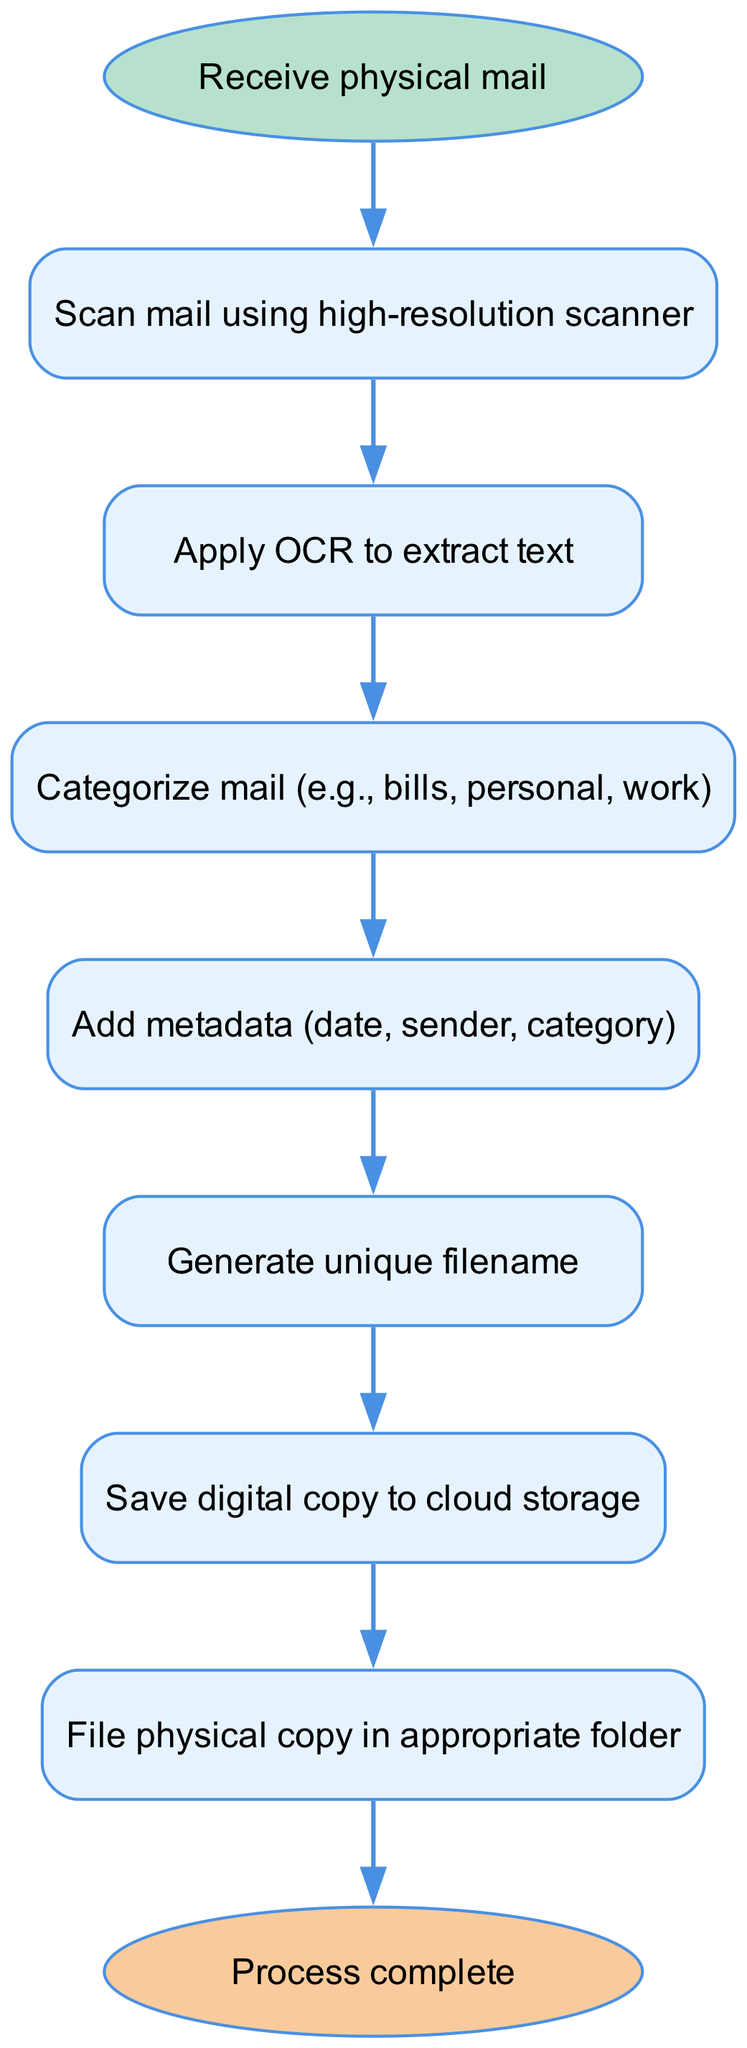What is the first step in the flowchart? The first node in the diagram is labeled "Receive physical mail," which represents the initial action taken in the digitization process.
Answer: Receive physical mail How many nodes are present in the diagram? By counting, there are a total of nine nodes listed in the data provided, including both the start and end nodes.
Answer: Nine What step comes after "Apply OCR to extract text"? The edge leading from "Apply OCR to extract text" points to the next node, which is "Categorize mail (e.g., bills, personal, work)," indicating the subsequent action after applying OCR.
Answer: Categorize mail (e.g., bills, personal, work) What type of node is "Save digital copy to cloud storage"? The node "Save digital copy to cloud storage" is categorized as a regular process step node, which describes a specific action taken in the flow of digitizing the mail.
Answer: Process step Which two nodes are connected directly to "Categorize mail"? The nodes "Apply OCR to extract text" connects to "Categorize mail" in the flow, and "Categorize mail" connects to "Add metadata (date, sender, category)." Hence, the direct connections related to "Categorize mail" are from "Apply OCR" and to "Add metadata."
Answer: Apply OCR to extract text, Add metadata (date, sender, category) What is the final step in the flowchart? The last node in the flowchart is labeled "Process complete," indicating the conclusion of the entire digitization process, with an edge leading to it from the previous step.
Answer: Process complete What type of structure does this diagram represent? The flowchart represents a directed graph structure, where nodes signify steps in the process and directed edges indicate the flow from one step to another in a sequential manner.
Answer: Directed graph What is the purpose of the "Generate unique filename" step? This step serves to create a distinctive identifier for each scanned document, ensuring that each file can be easily referenced or retrieved in future operations.
Answer: Create a distinctive identifier How are the physical copies handled after digitization? The final step in the diagram indicates that physical copies of the mail are filed in the appropriate folder once they have been scanned and digitized, suggesting a systematic approach to physical mail organization.
Answer: Filed in the appropriate folder 